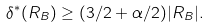<formula> <loc_0><loc_0><loc_500><loc_500>\delta ^ { * } ( R _ { B } ) \geq ( 3 / 2 + \alpha / 2 ) | R _ { B } | .</formula> 